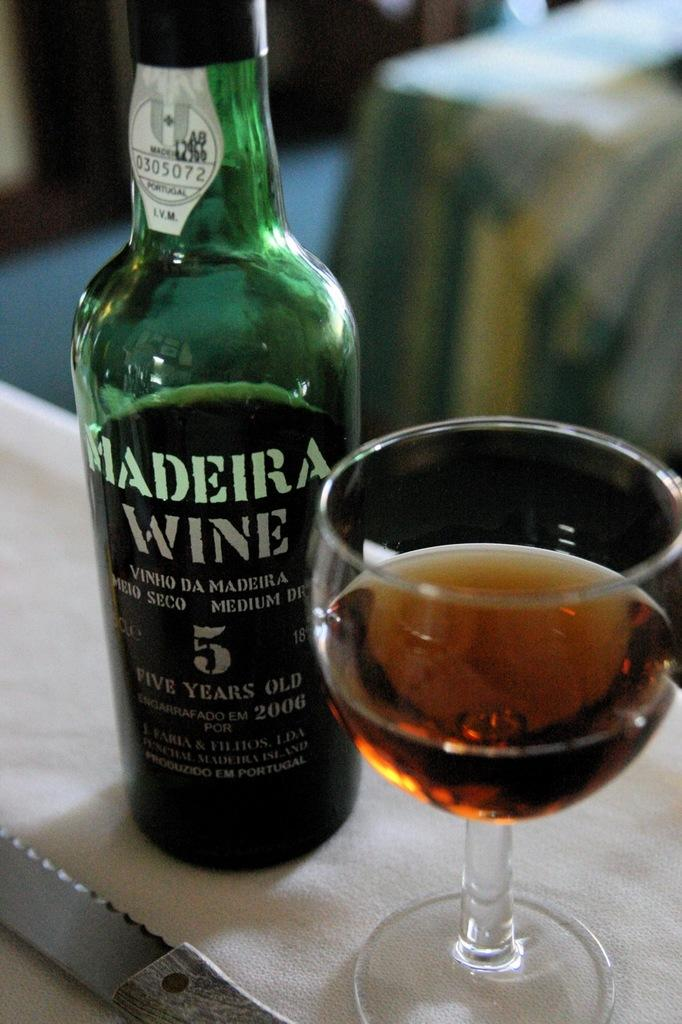<image>
Render a clear and concise summary of the photo. A bottle of Madeira Wine is next to a wine glass that is half full. 